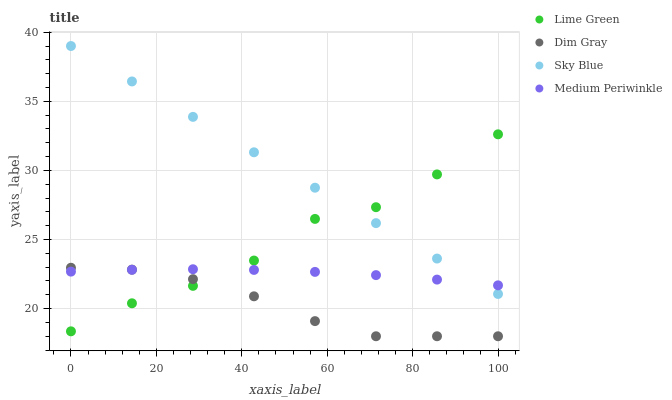Does Dim Gray have the minimum area under the curve?
Answer yes or no. Yes. Does Sky Blue have the maximum area under the curve?
Answer yes or no. Yes. Does Lime Green have the minimum area under the curve?
Answer yes or no. No. Does Lime Green have the maximum area under the curve?
Answer yes or no. No. Is Sky Blue the smoothest?
Answer yes or no. Yes. Is Lime Green the roughest?
Answer yes or no. Yes. Is Dim Gray the smoothest?
Answer yes or no. No. Is Dim Gray the roughest?
Answer yes or no. No. Does Dim Gray have the lowest value?
Answer yes or no. Yes. Does Lime Green have the lowest value?
Answer yes or no. No. Does Sky Blue have the highest value?
Answer yes or no. Yes. Does Dim Gray have the highest value?
Answer yes or no. No. Is Dim Gray less than Sky Blue?
Answer yes or no. Yes. Is Sky Blue greater than Dim Gray?
Answer yes or no. Yes. Does Lime Green intersect Medium Periwinkle?
Answer yes or no. Yes. Is Lime Green less than Medium Periwinkle?
Answer yes or no. No. Is Lime Green greater than Medium Periwinkle?
Answer yes or no. No. Does Dim Gray intersect Sky Blue?
Answer yes or no. No. 